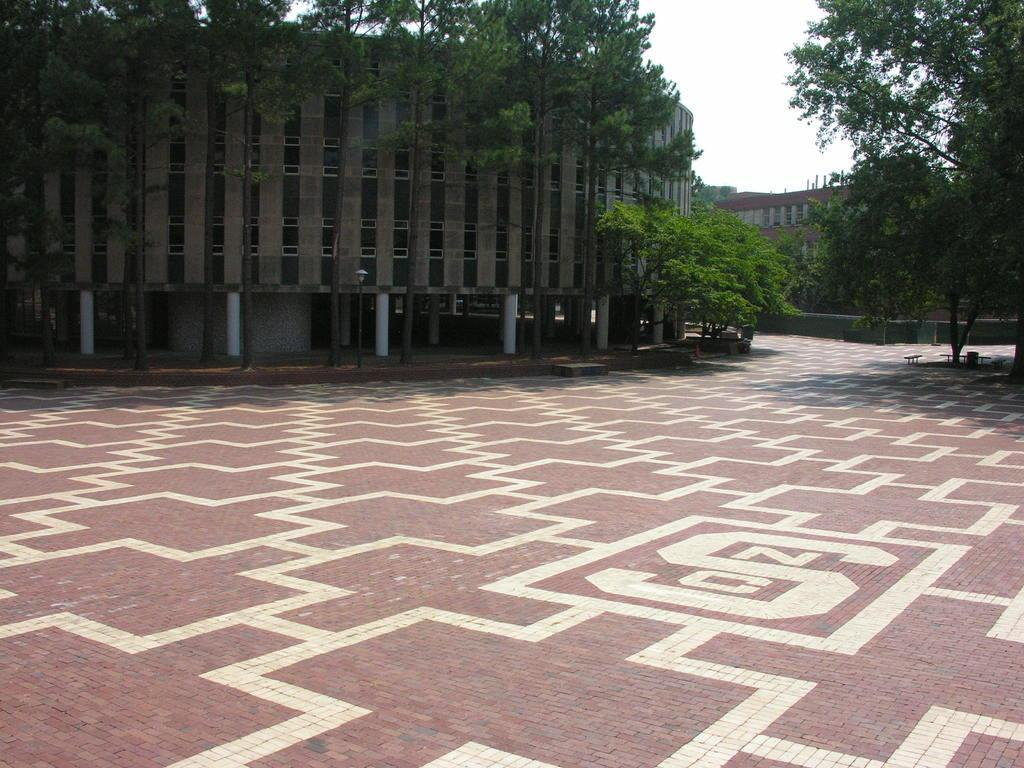What can be seen on the floor in the image? There is a white design on the floor in the image. How many buildings are visible in the image? There are two buildings, one on the left side and one on the right side of the image. What type of vegetation is present in the image? There are trees visible in the image. What is the condition of the sky in the image? The sky is clear in the image. What type of joke is being told by the trees in the image? There are no jokes being told by the trees in the image, as trees do not have the ability to tell jokes. How many cats are visible in the image? There are no cats present in the image. 